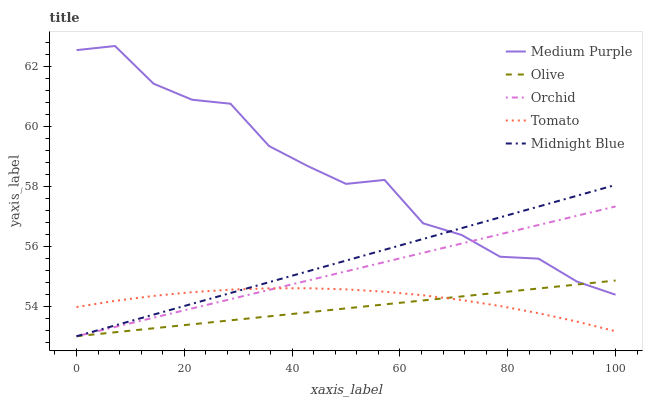Does Olive have the minimum area under the curve?
Answer yes or no. Yes. Does Medium Purple have the maximum area under the curve?
Answer yes or no. Yes. Does Tomato have the minimum area under the curve?
Answer yes or no. No. Does Tomato have the maximum area under the curve?
Answer yes or no. No. Is Orchid the smoothest?
Answer yes or no. Yes. Is Medium Purple the roughest?
Answer yes or no. Yes. Is Olive the smoothest?
Answer yes or no. No. Is Olive the roughest?
Answer yes or no. No. Does Olive have the lowest value?
Answer yes or no. Yes. Does Tomato have the lowest value?
Answer yes or no. No. Does Medium Purple have the highest value?
Answer yes or no. Yes. Does Olive have the highest value?
Answer yes or no. No. Is Tomato less than Medium Purple?
Answer yes or no. Yes. Is Medium Purple greater than Tomato?
Answer yes or no. Yes. Does Midnight Blue intersect Olive?
Answer yes or no. Yes. Is Midnight Blue less than Olive?
Answer yes or no. No. Is Midnight Blue greater than Olive?
Answer yes or no. No. Does Tomato intersect Medium Purple?
Answer yes or no. No. 